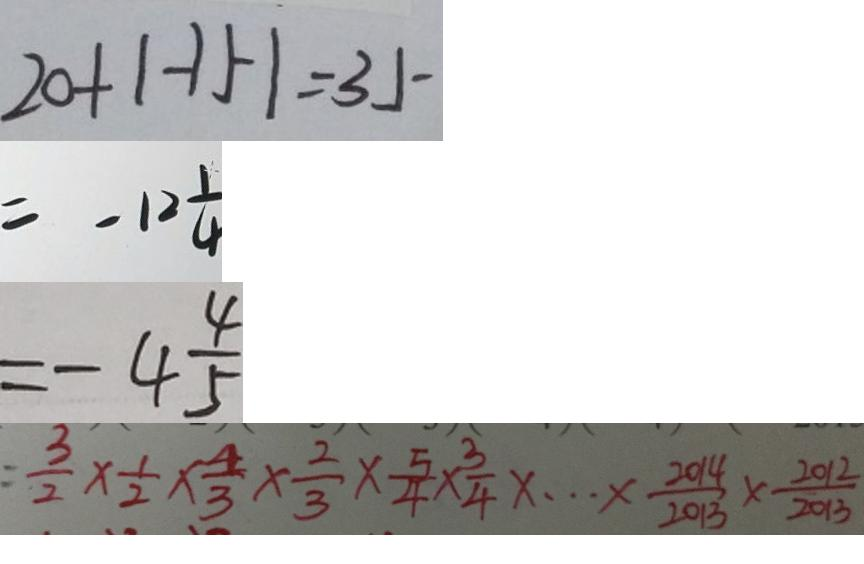<formula> <loc_0><loc_0><loc_500><loc_500>2 0 + \vert - 1 5 \vert = 3 5 
 = - 1 2 \frac { 1 } { 4 } 
 = - 4 \frac { 4 } { 5 } 
 = \frac { 3 } { 2 } \times \frac { 1 } { 2 } \times \frac { 4 } { 3 } \times \frac { 2 } { 3 } \times \frac { 5 } { 4 } \times \frac { 3 } { 4 } \times \cdots \times \frac { 2 0 1 4 } { 2 0 1 3 } \times \frac { 2 0 1 2 } { 2 0 1 3 }</formula> 